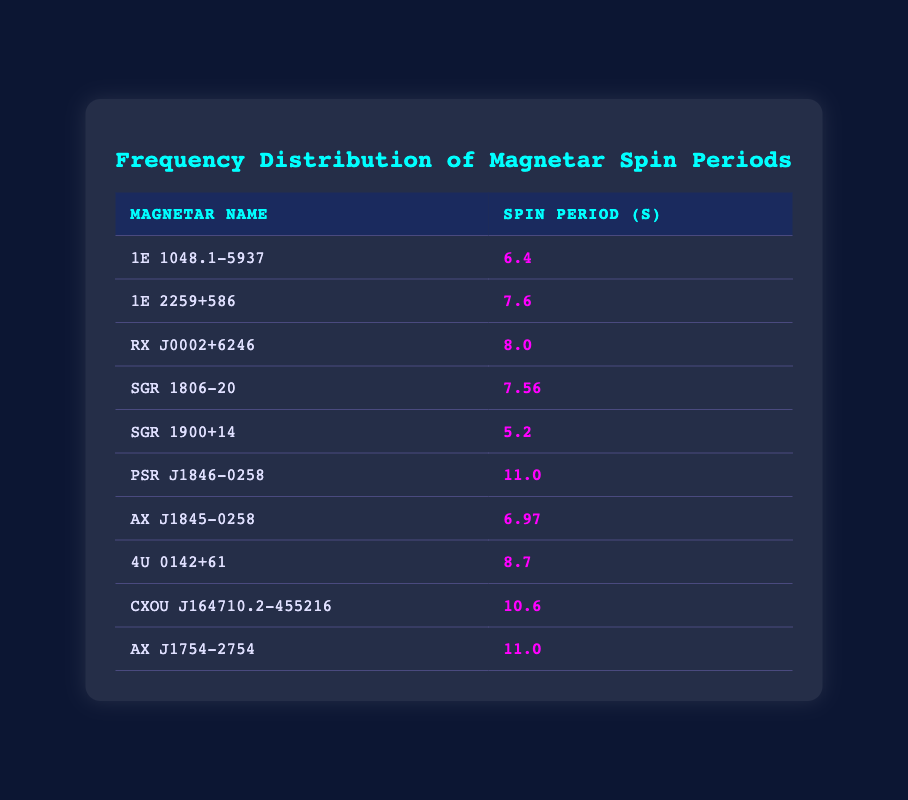What is the spin period of SGR 1900+14? The table lists the spin periods for each magnetar. Looking at the row for SGR 1900+14, the spin period is given directly as 5.2 seconds.
Answer: 5.2 How many magnetars have a spin period greater than 10 seconds? By examining the spin periods in the table, only PSR J1846-0258 and AX J1754-2754 have spin periods of 11.0 seconds and CXOU J164710.2-455216 has a spin period of 10.6 seconds. Hence, there are three magnetars with spin periods greater than 10 seconds.
Answer: 3 What is the average spin period of all the magnetars listed in the table? To find the average, we sum the spin periods: 6.4 + 7.6 + 8.0 + 7.56 + 5.2 + 11.0 + 6.97 + 8.7 + 10.6 + 11.0 =  77.19 seconds. Then, divide by the number of magnetars (10): 77.19 / 10 = 7.719 seconds, which rounds to 7.72 seconds.
Answer: 7.72 Is there any magnetar in the table with a spin period of exactly 6.0 seconds? Reviewing the spin periods in the table shows that none of the magnetars have a spin period listed as 6.0 seconds; the closest is 6.4 seconds. Therefore, the answer is no.
Answer: No Which magnetar has the longest spin period? The longest spin period can be found by looking at the spin periods listed in the table. PSR J1846-0258 and AX J1754-2754 both have the longest spin periods at 11.0 seconds.
Answer: PSR J1846-0258 and AX J1754-2754 